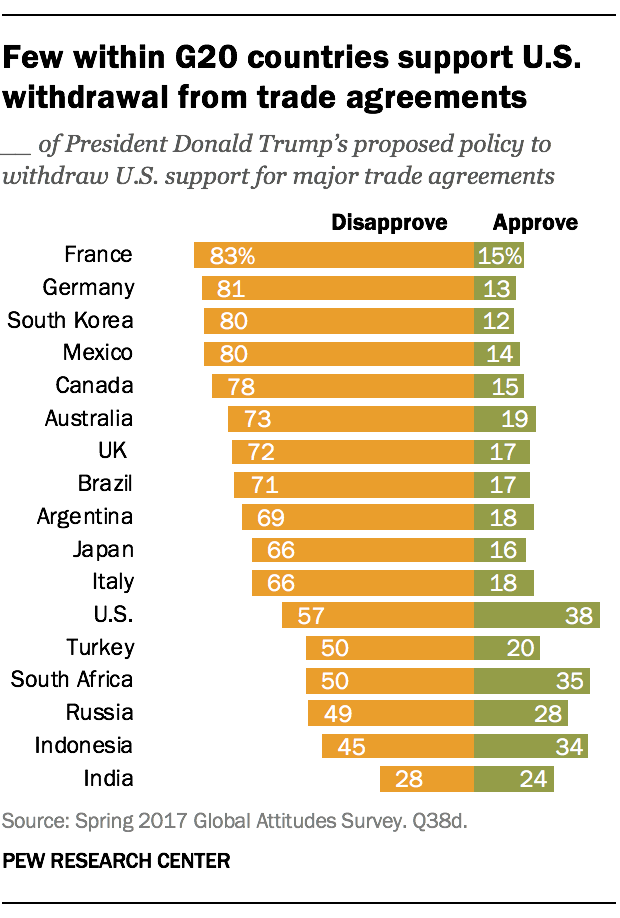Mention a couple of crucial points in this snapshot. The total value of the last three green bars is 86. The color of the rightmost bar is green. 